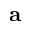Convert formula to latex. <formula><loc_0><loc_0><loc_500><loc_500>a</formula> 